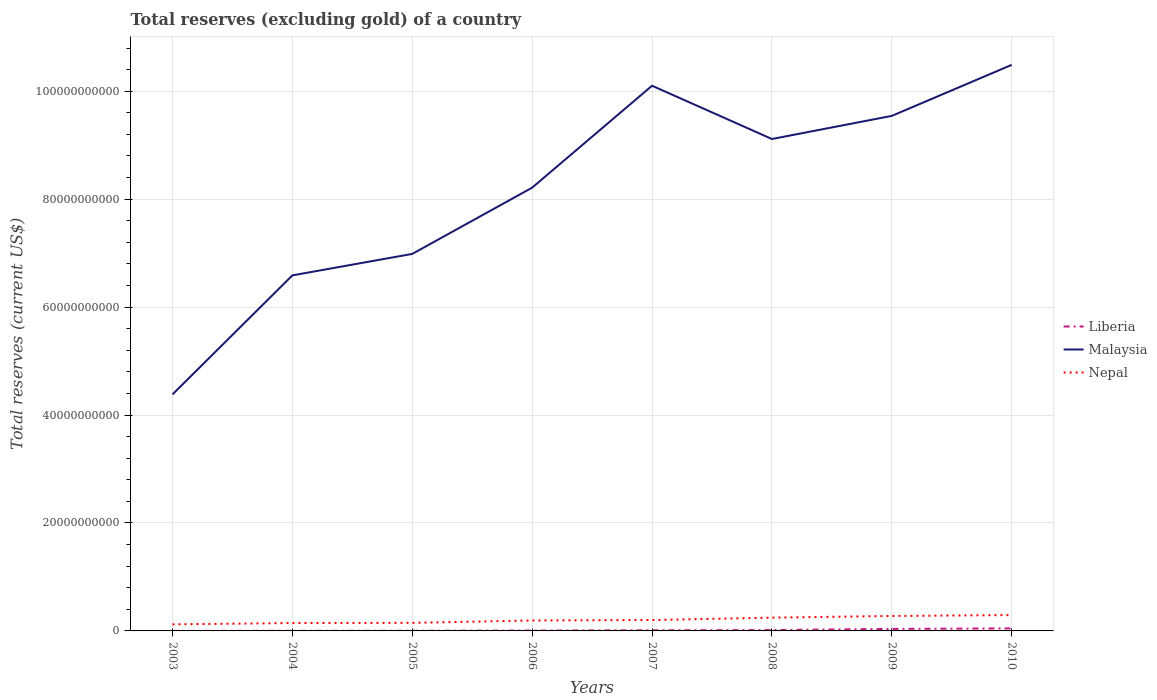How many different coloured lines are there?
Give a very brief answer. 3. Across all years, what is the maximum total reserves (excluding gold) in Liberia?
Offer a very short reply. 7.38e+06. In which year was the total reserves (excluding gold) in Nepal maximum?
Ensure brevity in your answer.  2003. What is the total total reserves (excluding gold) in Nepal in the graph?
Offer a very short reply. -7.85e+07. What is the difference between the highest and the second highest total reserves (excluding gold) in Malaysia?
Provide a short and direct response. 6.11e+1. How many years are there in the graph?
Provide a short and direct response. 8. Are the values on the major ticks of Y-axis written in scientific E-notation?
Your answer should be compact. No. How many legend labels are there?
Give a very brief answer. 3. How are the legend labels stacked?
Ensure brevity in your answer.  Vertical. What is the title of the graph?
Your response must be concise. Total reserves (excluding gold) of a country. Does "Haiti" appear as one of the legend labels in the graph?
Make the answer very short. No. What is the label or title of the X-axis?
Offer a terse response. Years. What is the label or title of the Y-axis?
Give a very brief answer. Total reserves (current US$). What is the Total reserves (current US$) of Liberia in 2003?
Ensure brevity in your answer.  7.38e+06. What is the Total reserves (current US$) in Malaysia in 2003?
Keep it short and to the point. 4.38e+1. What is the Total reserves (current US$) of Nepal in 2003?
Your answer should be compact. 1.22e+09. What is the Total reserves (current US$) of Liberia in 2004?
Your answer should be compact. 1.87e+07. What is the Total reserves (current US$) in Malaysia in 2004?
Give a very brief answer. 6.59e+1. What is the Total reserves (current US$) in Nepal in 2004?
Your answer should be very brief. 1.46e+09. What is the Total reserves (current US$) of Liberia in 2005?
Provide a short and direct response. 2.54e+07. What is the Total reserves (current US$) of Malaysia in 2005?
Provide a short and direct response. 6.99e+1. What is the Total reserves (current US$) of Nepal in 2005?
Offer a very short reply. 1.50e+09. What is the Total reserves (current US$) in Liberia in 2006?
Keep it short and to the point. 7.20e+07. What is the Total reserves (current US$) of Malaysia in 2006?
Offer a very short reply. 8.21e+1. What is the Total reserves (current US$) of Nepal in 2006?
Give a very brief answer. 1.94e+09. What is the Total reserves (current US$) in Liberia in 2007?
Your answer should be compact. 1.19e+08. What is the Total reserves (current US$) of Malaysia in 2007?
Ensure brevity in your answer.  1.01e+11. What is the Total reserves (current US$) in Nepal in 2007?
Provide a short and direct response. 2.01e+09. What is the Total reserves (current US$) in Liberia in 2008?
Your answer should be compact. 1.61e+08. What is the Total reserves (current US$) of Malaysia in 2008?
Your answer should be compact. 9.11e+1. What is the Total reserves (current US$) in Nepal in 2008?
Keep it short and to the point. 2.46e+09. What is the Total reserves (current US$) in Liberia in 2009?
Your answer should be very brief. 3.72e+08. What is the Total reserves (current US$) in Malaysia in 2009?
Your answer should be compact. 9.54e+1. What is the Total reserves (current US$) of Nepal in 2009?
Offer a terse response. 2.77e+09. What is the Total reserves (current US$) in Liberia in 2010?
Your response must be concise. 4.66e+08. What is the Total reserves (current US$) in Malaysia in 2010?
Ensure brevity in your answer.  1.05e+11. What is the Total reserves (current US$) in Nepal in 2010?
Give a very brief answer. 2.94e+09. Across all years, what is the maximum Total reserves (current US$) of Liberia?
Provide a short and direct response. 4.66e+08. Across all years, what is the maximum Total reserves (current US$) in Malaysia?
Ensure brevity in your answer.  1.05e+11. Across all years, what is the maximum Total reserves (current US$) in Nepal?
Provide a succinct answer. 2.94e+09. Across all years, what is the minimum Total reserves (current US$) in Liberia?
Make the answer very short. 7.38e+06. Across all years, what is the minimum Total reserves (current US$) of Malaysia?
Keep it short and to the point. 4.38e+1. Across all years, what is the minimum Total reserves (current US$) of Nepal?
Make the answer very short. 1.22e+09. What is the total Total reserves (current US$) in Liberia in the graph?
Offer a terse response. 1.24e+09. What is the total Total reserves (current US$) in Malaysia in the graph?
Offer a very short reply. 6.54e+11. What is the total Total reserves (current US$) of Nepal in the graph?
Give a very brief answer. 1.63e+1. What is the difference between the Total reserves (current US$) of Liberia in 2003 and that in 2004?
Your answer should be very brief. -1.14e+07. What is the difference between the Total reserves (current US$) of Malaysia in 2003 and that in 2004?
Your answer should be compact. -2.21e+1. What is the difference between the Total reserves (current US$) in Nepal in 2003 and that in 2004?
Keep it short and to the point. -2.40e+08. What is the difference between the Total reserves (current US$) in Liberia in 2003 and that in 2005?
Provide a short and direct response. -1.80e+07. What is the difference between the Total reserves (current US$) in Malaysia in 2003 and that in 2005?
Your answer should be compact. -2.60e+1. What is the difference between the Total reserves (current US$) of Nepal in 2003 and that in 2005?
Give a very brief answer. -2.77e+08. What is the difference between the Total reserves (current US$) in Liberia in 2003 and that in 2006?
Give a very brief answer. -6.46e+07. What is the difference between the Total reserves (current US$) in Malaysia in 2003 and that in 2006?
Offer a very short reply. -3.83e+1. What is the difference between the Total reserves (current US$) in Nepal in 2003 and that in 2006?
Your response must be concise. -7.13e+08. What is the difference between the Total reserves (current US$) of Liberia in 2003 and that in 2007?
Your answer should be compact. -1.12e+08. What is the difference between the Total reserves (current US$) of Malaysia in 2003 and that in 2007?
Provide a short and direct response. -5.72e+1. What is the difference between the Total reserves (current US$) in Nepal in 2003 and that in 2007?
Keep it short and to the point. -7.92e+08. What is the difference between the Total reserves (current US$) of Liberia in 2003 and that in 2008?
Your answer should be very brief. -1.53e+08. What is the difference between the Total reserves (current US$) in Malaysia in 2003 and that in 2008?
Provide a short and direct response. -4.73e+1. What is the difference between the Total reserves (current US$) in Nepal in 2003 and that in 2008?
Offer a very short reply. -1.24e+09. What is the difference between the Total reserves (current US$) of Liberia in 2003 and that in 2009?
Make the answer very short. -3.65e+08. What is the difference between the Total reserves (current US$) in Malaysia in 2003 and that in 2009?
Provide a short and direct response. -5.16e+1. What is the difference between the Total reserves (current US$) of Nepal in 2003 and that in 2009?
Provide a short and direct response. -1.55e+09. What is the difference between the Total reserves (current US$) in Liberia in 2003 and that in 2010?
Offer a very short reply. -4.59e+08. What is the difference between the Total reserves (current US$) of Malaysia in 2003 and that in 2010?
Keep it short and to the point. -6.11e+1. What is the difference between the Total reserves (current US$) in Nepal in 2003 and that in 2010?
Your response must be concise. -1.71e+09. What is the difference between the Total reserves (current US$) of Liberia in 2004 and that in 2005?
Your response must be concise. -6.65e+06. What is the difference between the Total reserves (current US$) of Malaysia in 2004 and that in 2005?
Your response must be concise. -3.98e+09. What is the difference between the Total reserves (current US$) of Nepal in 2004 and that in 2005?
Your answer should be very brief. -3.68e+07. What is the difference between the Total reserves (current US$) in Liberia in 2004 and that in 2006?
Your response must be concise. -5.32e+07. What is the difference between the Total reserves (current US$) in Malaysia in 2004 and that in 2006?
Your answer should be compact. -1.63e+1. What is the difference between the Total reserves (current US$) in Nepal in 2004 and that in 2006?
Provide a succinct answer. -4.73e+08. What is the difference between the Total reserves (current US$) of Liberia in 2004 and that in 2007?
Your response must be concise. -1.01e+08. What is the difference between the Total reserves (current US$) of Malaysia in 2004 and that in 2007?
Offer a terse response. -3.51e+1. What is the difference between the Total reserves (current US$) of Nepal in 2004 and that in 2007?
Offer a very short reply. -5.52e+08. What is the difference between the Total reserves (current US$) of Liberia in 2004 and that in 2008?
Keep it short and to the point. -1.42e+08. What is the difference between the Total reserves (current US$) in Malaysia in 2004 and that in 2008?
Offer a terse response. -2.53e+1. What is the difference between the Total reserves (current US$) in Nepal in 2004 and that in 2008?
Keep it short and to the point. -9.96e+08. What is the difference between the Total reserves (current US$) of Liberia in 2004 and that in 2009?
Make the answer very short. -3.54e+08. What is the difference between the Total reserves (current US$) of Malaysia in 2004 and that in 2009?
Give a very brief answer. -2.96e+1. What is the difference between the Total reserves (current US$) of Nepal in 2004 and that in 2009?
Provide a succinct answer. -1.31e+09. What is the difference between the Total reserves (current US$) of Liberia in 2004 and that in 2010?
Your response must be concise. -4.47e+08. What is the difference between the Total reserves (current US$) of Malaysia in 2004 and that in 2010?
Make the answer very short. -3.90e+1. What is the difference between the Total reserves (current US$) of Nepal in 2004 and that in 2010?
Keep it short and to the point. -1.47e+09. What is the difference between the Total reserves (current US$) of Liberia in 2005 and that in 2006?
Provide a short and direct response. -4.66e+07. What is the difference between the Total reserves (current US$) in Malaysia in 2005 and that in 2006?
Ensure brevity in your answer.  -1.23e+1. What is the difference between the Total reserves (current US$) in Nepal in 2005 and that in 2006?
Make the answer very short. -4.37e+08. What is the difference between the Total reserves (current US$) in Liberia in 2005 and that in 2007?
Give a very brief answer. -9.40e+07. What is the difference between the Total reserves (current US$) in Malaysia in 2005 and that in 2007?
Provide a succinct answer. -3.12e+1. What is the difference between the Total reserves (current US$) in Nepal in 2005 and that in 2007?
Keep it short and to the point. -5.15e+08. What is the difference between the Total reserves (current US$) of Liberia in 2005 and that in 2008?
Your answer should be very brief. -1.35e+08. What is the difference between the Total reserves (current US$) of Malaysia in 2005 and that in 2008?
Ensure brevity in your answer.  -2.13e+1. What is the difference between the Total reserves (current US$) in Nepal in 2005 and that in 2008?
Your answer should be compact. -9.59e+08. What is the difference between the Total reserves (current US$) in Liberia in 2005 and that in 2009?
Make the answer very short. -3.47e+08. What is the difference between the Total reserves (current US$) of Malaysia in 2005 and that in 2009?
Provide a short and direct response. -2.56e+1. What is the difference between the Total reserves (current US$) in Nepal in 2005 and that in 2009?
Ensure brevity in your answer.  -1.27e+09. What is the difference between the Total reserves (current US$) of Liberia in 2005 and that in 2010?
Ensure brevity in your answer.  -4.41e+08. What is the difference between the Total reserves (current US$) in Malaysia in 2005 and that in 2010?
Keep it short and to the point. -3.50e+1. What is the difference between the Total reserves (current US$) of Nepal in 2005 and that in 2010?
Your answer should be very brief. -1.44e+09. What is the difference between the Total reserves (current US$) in Liberia in 2006 and that in 2007?
Offer a terse response. -4.74e+07. What is the difference between the Total reserves (current US$) of Malaysia in 2006 and that in 2007?
Make the answer very short. -1.89e+1. What is the difference between the Total reserves (current US$) in Nepal in 2006 and that in 2007?
Provide a short and direct response. -7.85e+07. What is the difference between the Total reserves (current US$) in Liberia in 2006 and that in 2008?
Your answer should be very brief. -8.89e+07. What is the difference between the Total reserves (current US$) of Malaysia in 2006 and that in 2008?
Ensure brevity in your answer.  -9.02e+09. What is the difference between the Total reserves (current US$) of Nepal in 2006 and that in 2008?
Offer a very short reply. -5.22e+08. What is the difference between the Total reserves (current US$) in Liberia in 2006 and that in 2009?
Provide a short and direct response. -3.00e+08. What is the difference between the Total reserves (current US$) in Malaysia in 2006 and that in 2009?
Ensure brevity in your answer.  -1.33e+1. What is the difference between the Total reserves (current US$) of Nepal in 2006 and that in 2009?
Keep it short and to the point. -8.33e+08. What is the difference between the Total reserves (current US$) of Liberia in 2006 and that in 2010?
Keep it short and to the point. -3.94e+08. What is the difference between the Total reserves (current US$) of Malaysia in 2006 and that in 2010?
Provide a short and direct response. -2.28e+1. What is the difference between the Total reserves (current US$) in Nepal in 2006 and that in 2010?
Your response must be concise. -1.00e+09. What is the difference between the Total reserves (current US$) of Liberia in 2007 and that in 2008?
Ensure brevity in your answer.  -4.15e+07. What is the difference between the Total reserves (current US$) in Malaysia in 2007 and that in 2008?
Offer a very short reply. 9.87e+09. What is the difference between the Total reserves (current US$) of Nepal in 2007 and that in 2008?
Keep it short and to the point. -4.44e+08. What is the difference between the Total reserves (current US$) of Liberia in 2007 and that in 2009?
Provide a succinct answer. -2.53e+08. What is the difference between the Total reserves (current US$) of Malaysia in 2007 and that in 2009?
Your response must be concise. 5.59e+09. What is the difference between the Total reserves (current US$) in Nepal in 2007 and that in 2009?
Ensure brevity in your answer.  -7.55e+08. What is the difference between the Total reserves (current US$) of Liberia in 2007 and that in 2010?
Keep it short and to the point. -3.47e+08. What is the difference between the Total reserves (current US$) in Malaysia in 2007 and that in 2010?
Offer a very short reply. -3.86e+09. What is the difference between the Total reserves (current US$) in Nepal in 2007 and that in 2010?
Your answer should be very brief. -9.23e+08. What is the difference between the Total reserves (current US$) in Liberia in 2008 and that in 2009?
Ensure brevity in your answer.  -2.12e+08. What is the difference between the Total reserves (current US$) of Malaysia in 2008 and that in 2009?
Ensure brevity in your answer.  -4.28e+09. What is the difference between the Total reserves (current US$) of Nepal in 2008 and that in 2009?
Keep it short and to the point. -3.11e+08. What is the difference between the Total reserves (current US$) of Liberia in 2008 and that in 2010?
Make the answer very short. -3.05e+08. What is the difference between the Total reserves (current US$) in Malaysia in 2008 and that in 2010?
Give a very brief answer. -1.37e+1. What is the difference between the Total reserves (current US$) of Nepal in 2008 and that in 2010?
Keep it short and to the point. -4.79e+08. What is the difference between the Total reserves (current US$) in Liberia in 2009 and that in 2010?
Make the answer very short. -9.34e+07. What is the difference between the Total reserves (current US$) of Malaysia in 2009 and that in 2010?
Ensure brevity in your answer.  -9.45e+09. What is the difference between the Total reserves (current US$) in Nepal in 2009 and that in 2010?
Offer a terse response. -1.68e+08. What is the difference between the Total reserves (current US$) of Liberia in 2003 and the Total reserves (current US$) of Malaysia in 2004?
Your answer should be very brief. -6.59e+1. What is the difference between the Total reserves (current US$) of Liberia in 2003 and the Total reserves (current US$) of Nepal in 2004?
Provide a short and direct response. -1.45e+09. What is the difference between the Total reserves (current US$) of Malaysia in 2003 and the Total reserves (current US$) of Nepal in 2004?
Keep it short and to the point. 4.24e+1. What is the difference between the Total reserves (current US$) of Liberia in 2003 and the Total reserves (current US$) of Malaysia in 2005?
Make the answer very short. -6.99e+1. What is the difference between the Total reserves (current US$) of Liberia in 2003 and the Total reserves (current US$) of Nepal in 2005?
Give a very brief answer. -1.49e+09. What is the difference between the Total reserves (current US$) of Malaysia in 2003 and the Total reserves (current US$) of Nepal in 2005?
Offer a very short reply. 4.23e+1. What is the difference between the Total reserves (current US$) in Liberia in 2003 and the Total reserves (current US$) in Malaysia in 2006?
Keep it short and to the point. -8.21e+1. What is the difference between the Total reserves (current US$) of Liberia in 2003 and the Total reserves (current US$) of Nepal in 2006?
Your answer should be very brief. -1.93e+09. What is the difference between the Total reserves (current US$) in Malaysia in 2003 and the Total reserves (current US$) in Nepal in 2006?
Your answer should be very brief. 4.19e+1. What is the difference between the Total reserves (current US$) of Liberia in 2003 and the Total reserves (current US$) of Malaysia in 2007?
Provide a short and direct response. -1.01e+11. What is the difference between the Total reserves (current US$) of Liberia in 2003 and the Total reserves (current US$) of Nepal in 2007?
Make the answer very short. -2.01e+09. What is the difference between the Total reserves (current US$) in Malaysia in 2003 and the Total reserves (current US$) in Nepal in 2007?
Offer a terse response. 4.18e+1. What is the difference between the Total reserves (current US$) in Liberia in 2003 and the Total reserves (current US$) in Malaysia in 2008?
Give a very brief answer. -9.11e+1. What is the difference between the Total reserves (current US$) of Liberia in 2003 and the Total reserves (current US$) of Nepal in 2008?
Your response must be concise. -2.45e+09. What is the difference between the Total reserves (current US$) in Malaysia in 2003 and the Total reserves (current US$) in Nepal in 2008?
Provide a short and direct response. 4.14e+1. What is the difference between the Total reserves (current US$) of Liberia in 2003 and the Total reserves (current US$) of Malaysia in 2009?
Your answer should be very brief. -9.54e+1. What is the difference between the Total reserves (current US$) of Liberia in 2003 and the Total reserves (current US$) of Nepal in 2009?
Offer a very short reply. -2.76e+09. What is the difference between the Total reserves (current US$) in Malaysia in 2003 and the Total reserves (current US$) in Nepal in 2009?
Provide a succinct answer. 4.11e+1. What is the difference between the Total reserves (current US$) of Liberia in 2003 and the Total reserves (current US$) of Malaysia in 2010?
Ensure brevity in your answer.  -1.05e+11. What is the difference between the Total reserves (current US$) in Liberia in 2003 and the Total reserves (current US$) in Nepal in 2010?
Your answer should be compact. -2.93e+09. What is the difference between the Total reserves (current US$) in Malaysia in 2003 and the Total reserves (current US$) in Nepal in 2010?
Provide a short and direct response. 4.09e+1. What is the difference between the Total reserves (current US$) in Liberia in 2004 and the Total reserves (current US$) in Malaysia in 2005?
Your response must be concise. -6.98e+1. What is the difference between the Total reserves (current US$) in Liberia in 2004 and the Total reserves (current US$) in Nepal in 2005?
Your answer should be very brief. -1.48e+09. What is the difference between the Total reserves (current US$) in Malaysia in 2004 and the Total reserves (current US$) in Nepal in 2005?
Your answer should be compact. 6.44e+1. What is the difference between the Total reserves (current US$) in Liberia in 2004 and the Total reserves (current US$) in Malaysia in 2006?
Your answer should be compact. -8.21e+1. What is the difference between the Total reserves (current US$) in Liberia in 2004 and the Total reserves (current US$) in Nepal in 2006?
Make the answer very short. -1.92e+09. What is the difference between the Total reserves (current US$) in Malaysia in 2004 and the Total reserves (current US$) in Nepal in 2006?
Your answer should be compact. 6.39e+1. What is the difference between the Total reserves (current US$) of Liberia in 2004 and the Total reserves (current US$) of Malaysia in 2007?
Offer a very short reply. -1.01e+11. What is the difference between the Total reserves (current US$) of Liberia in 2004 and the Total reserves (current US$) of Nepal in 2007?
Your answer should be compact. -2.00e+09. What is the difference between the Total reserves (current US$) in Malaysia in 2004 and the Total reserves (current US$) in Nepal in 2007?
Your answer should be very brief. 6.39e+1. What is the difference between the Total reserves (current US$) in Liberia in 2004 and the Total reserves (current US$) in Malaysia in 2008?
Your answer should be compact. -9.11e+1. What is the difference between the Total reserves (current US$) of Liberia in 2004 and the Total reserves (current US$) of Nepal in 2008?
Your response must be concise. -2.44e+09. What is the difference between the Total reserves (current US$) of Malaysia in 2004 and the Total reserves (current US$) of Nepal in 2008?
Offer a very short reply. 6.34e+1. What is the difference between the Total reserves (current US$) of Liberia in 2004 and the Total reserves (current US$) of Malaysia in 2009?
Provide a short and direct response. -9.54e+1. What is the difference between the Total reserves (current US$) in Liberia in 2004 and the Total reserves (current US$) in Nepal in 2009?
Offer a terse response. -2.75e+09. What is the difference between the Total reserves (current US$) of Malaysia in 2004 and the Total reserves (current US$) of Nepal in 2009?
Your response must be concise. 6.31e+1. What is the difference between the Total reserves (current US$) in Liberia in 2004 and the Total reserves (current US$) in Malaysia in 2010?
Offer a very short reply. -1.05e+11. What is the difference between the Total reserves (current US$) in Liberia in 2004 and the Total reserves (current US$) in Nepal in 2010?
Offer a very short reply. -2.92e+09. What is the difference between the Total reserves (current US$) in Malaysia in 2004 and the Total reserves (current US$) in Nepal in 2010?
Provide a short and direct response. 6.29e+1. What is the difference between the Total reserves (current US$) of Liberia in 2005 and the Total reserves (current US$) of Malaysia in 2006?
Offer a very short reply. -8.21e+1. What is the difference between the Total reserves (current US$) of Liberia in 2005 and the Total reserves (current US$) of Nepal in 2006?
Provide a short and direct response. -1.91e+09. What is the difference between the Total reserves (current US$) in Malaysia in 2005 and the Total reserves (current US$) in Nepal in 2006?
Keep it short and to the point. 6.79e+1. What is the difference between the Total reserves (current US$) of Liberia in 2005 and the Total reserves (current US$) of Malaysia in 2007?
Your response must be concise. -1.01e+11. What is the difference between the Total reserves (current US$) of Liberia in 2005 and the Total reserves (current US$) of Nepal in 2007?
Keep it short and to the point. -1.99e+09. What is the difference between the Total reserves (current US$) of Malaysia in 2005 and the Total reserves (current US$) of Nepal in 2007?
Provide a short and direct response. 6.78e+1. What is the difference between the Total reserves (current US$) in Liberia in 2005 and the Total reserves (current US$) in Malaysia in 2008?
Offer a terse response. -9.11e+1. What is the difference between the Total reserves (current US$) in Liberia in 2005 and the Total reserves (current US$) in Nepal in 2008?
Your response must be concise. -2.43e+09. What is the difference between the Total reserves (current US$) in Malaysia in 2005 and the Total reserves (current US$) in Nepal in 2008?
Offer a very short reply. 6.74e+1. What is the difference between the Total reserves (current US$) in Liberia in 2005 and the Total reserves (current US$) in Malaysia in 2009?
Give a very brief answer. -9.54e+1. What is the difference between the Total reserves (current US$) of Liberia in 2005 and the Total reserves (current US$) of Nepal in 2009?
Offer a terse response. -2.74e+09. What is the difference between the Total reserves (current US$) in Malaysia in 2005 and the Total reserves (current US$) in Nepal in 2009?
Provide a short and direct response. 6.71e+1. What is the difference between the Total reserves (current US$) of Liberia in 2005 and the Total reserves (current US$) of Malaysia in 2010?
Give a very brief answer. -1.05e+11. What is the difference between the Total reserves (current US$) in Liberia in 2005 and the Total reserves (current US$) in Nepal in 2010?
Ensure brevity in your answer.  -2.91e+09. What is the difference between the Total reserves (current US$) of Malaysia in 2005 and the Total reserves (current US$) of Nepal in 2010?
Your answer should be very brief. 6.69e+1. What is the difference between the Total reserves (current US$) of Liberia in 2006 and the Total reserves (current US$) of Malaysia in 2007?
Give a very brief answer. -1.01e+11. What is the difference between the Total reserves (current US$) in Liberia in 2006 and the Total reserves (current US$) in Nepal in 2007?
Your answer should be compact. -1.94e+09. What is the difference between the Total reserves (current US$) of Malaysia in 2006 and the Total reserves (current US$) of Nepal in 2007?
Give a very brief answer. 8.01e+1. What is the difference between the Total reserves (current US$) in Liberia in 2006 and the Total reserves (current US$) in Malaysia in 2008?
Ensure brevity in your answer.  -9.11e+1. What is the difference between the Total reserves (current US$) in Liberia in 2006 and the Total reserves (current US$) in Nepal in 2008?
Your response must be concise. -2.39e+09. What is the difference between the Total reserves (current US$) of Malaysia in 2006 and the Total reserves (current US$) of Nepal in 2008?
Offer a terse response. 7.97e+1. What is the difference between the Total reserves (current US$) of Liberia in 2006 and the Total reserves (current US$) of Malaysia in 2009?
Keep it short and to the point. -9.54e+1. What is the difference between the Total reserves (current US$) of Liberia in 2006 and the Total reserves (current US$) of Nepal in 2009?
Provide a short and direct response. -2.70e+09. What is the difference between the Total reserves (current US$) in Malaysia in 2006 and the Total reserves (current US$) in Nepal in 2009?
Offer a terse response. 7.94e+1. What is the difference between the Total reserves (current US$) in Liberia in 2006 and the Total reserves (current US$) in Malaysia in 2010?
Your answer should be very brief. -1.05e+11. What is the difference between the Total reserves (current US$) of Liberia in 2006 and the Total reserves (current US$) of Nepal in 2010?
Your answer should be compact. -2.86e+09. What is the difference between the Total reserves (current US$) of Malaysia in 2006 and the Total reserves (current US$) of Nepal in 2010?
Offer a terse response. 7.92e+1. What is the difference between the Total reserves (current US$) of Liberia in 2007 and the Total reserves (current US$) of Malaysia in 2008?
Offer a very short reply. -9.10e+1. What is the difference between the Total reserves (current US$) of Liberia in 2007 and the Total reserves (current US$) of Nepal in 2008?
Ensure brevity in your answer.  -2.34e+09. What is the difference between the Total reserves (current US$) of Malaysia in 2007 and the Total reserves (current US$) of Nepal in 2008?
Provide a succinct answer. 9.86e+1. What is the difference between the Total reserves (current US$) in Liberia in 2007 and the Total reserves (current US$) in Malaysia in 2009?
Offer a terse response. -9.53e+1. What is the difference between the Total reserves (current US$) of Liberia in 2007 and the Total reserves (current US$) of Nepal in 2009?
Provide a short and direct response. -2.65e+09. What is the difference between the Total reserves (current US$) of Malaysia in 2007 and the Total reserves (current US$) of Nepal in 2009?
Your response must be concise. 9.83e+1. What is the difference between the Total reserves (current US$) in Liberia in 2007 and the Total reserves (current US$) in Malaysia in 2010?
Provide a short and direct response. -1.05e+11. What is the difference between the Total reserves (current US$) in Liberia in 2007 and the Total reserves (current US$) in Nepal in 2010?
Offer a terse response. -2.82e+09. What is the difference between the Total reserves (current US$) in Malaysia in 2007 and the Total reserves (current US$) in Nepal in 2010?
Make the answer very short. 9.81e+1. What is the difference between the Total reserves (current US$) of Liberia in 2008 and the Total reserves (current US$) of Malaysia in 2009?
Make the answer very short. -9.53e+1. What is the difference between the Total reserves (current US$) in Liberia in 2008 and the Total reserves (current US$) in Nepal in 2009?
Make the answer very short. -2.61e+09. What is the difference between the Total reserves (current US$) in Malaysia in 2008 and the Total reserves (current US$) in Nepal in 2009?
Keep it short and to the point. 8.84e+1. What is the difference between the Total reserves (current US$) of Liberia in 2008 and the Total reserves (current US$) of Malaysia in 2010?
Offer a terse response. -1.05e+11. What is the difference between the Total reserves (current US$) in Liberia in 2008 and the Total reserves (current US$) in Nepal in 2010?
Your response must be concise. -2.78e+09. What is the difference between the Total reserves (current US$) in Malaysia in 2008 and the Total reserves (current US$) in Nepal in 2010?
Offer a terse response. 8.82e+1. What is the difference between the Total reserves (current US$) of Liberia in 2009 and the Total reserves (current US$) of Malaysia in 2010?
Offer a very short reply. -1.05e+11. What is the difference between the Total reserves (current US$) of Liberia in 2009 and the Total reserves (current US$) of Nepal in 2010?
Keep it short and to the point. -2.56e+09. What is the difference between the Total reserves (current US$) of Malaysia in 2009 and the Total reserves (current US$) of Nepal in 2010?
Your answer should be very brief. 9.25e+1. What is the average Total reserves (current US$) in Liberia per year?
Offer a terse response. 1.55e+08. What is the average Total reserves (current US$) in Malaysia per year?
Your answer should be very brief. 8.18e+1. What is the average Total reserves (current US$) in Nepal per year?
Keep it short and to the point. 2.04e+09. In the year 2003, what is the difference between the Total reserves (current US$) in Liberia and Total reserves (current US$) in Malaysia?
Provide a short and direct response. -4.38e+1. In the year 2003, what is the difference between the Total reserves (current US$) of Liberia and Total reserves (current US$) of Nepal?
Provide a succinct answer. -1.22e+09. In the year 2003, what is the difference between the Total reserves (current US$) of Malaysia and Total reserves (current US$) of Nepal?
Keep it short and to the point. 4.26e+1. In the year 2004, what is the difference between the Total reserves (current US$) in Liberia and Total reserves (current US$) in Malaysia?
Offer a terse response. -6.59e+1. In the year 2004, what is the difference between the Total reserves (current US$) in Liberia and Total reserves (current US$) in Nepal?
Offer a very short reply. -1.44e+09. In the year 2004, what is the difference between the Total reserves (current US$) of Malaysia and Total reserves (current US$) of Nepal?
Ensure brevity in your answer.  6.44e+1. In the year 2005, what is the difference between the Total reserves (current US$) of Liberia and Total reserves (current US$) of Malaysia?
Your answer should be compact. -6.98e+1. In the year 2005, what is the difference between the Total reserves (current US$) of Liberia and Total reserves (current US$) of Nepal?
Your answer should be compact. -1.47e+09. In the year 2005, what is the difference between the Total reserves (current US$) of Malaysia and Total reserves (current US$) of Nepal?
Keep it short and to the point. 6.84e+1. In the year 2006, what is the difference between the Total reserves (current US$) in Liberia and Total reserves (current US$) in Malaysia?
Your answer should be compact. -8.21e+1. In the year 2006, what is the difference between the Total reserves (current US$) in Liberia and Total reserves (current US$) in Nepal?
Keep it short and to the point. -1.86e+09. In the year 2006, what is the difference between the Total reserves (current US$) in Malaysia and Total reserves (current US$) in Nepal?
Your answer should be compact. 8.02e+1. In the year 2007, what is the difference between the Total reserves (current US$) in Liberia and Total reserves (current US$) in Malaysia?
Ensure brevity in your answer.  -1.01e+11. In the year 2007, what is the difference between the Total reserves (current US$) in Liberia and Total reserves (current US$) in Nepal?
Provide a short and direct response. -1.89e+09. In the year 2007, what is the difference between the Total reserves (current US$) in Malaysia and Total reserves (current US$) in Nepal?
Provide a short and direct response. 9.90e+1. In the year 2008, what is the difference between the Total reserves (current US$) of Liberia and Total reserves (current US$) of Malaysia?
Give a very brief answer. -9.10e+1. In the year 2008, what is the difference between the Total reserves (current US$) in Liberia and Total reserves (current US$) in Nepal?
Your response must be concise. -2.30e+09. In the year 2008, what is the difference between the Total reserves (current US$) in Malaysia and Total reserves (current US$) in Nepal?
Keep it short and to the point. 8.87e+1. In the year 2009, what is the difference between the Total reserves (current US$) of Liberia and Total reserves (current US$) of Malaysia?
Give a very brief answer. -9.51e+1. In the year 2009, what is the difference between the Total reserves (current US$) of Liberia and Total reserves (current US$) of Nepal?
Provide a short and direct response. -2.40e+09. In the year 2009, what is the difference between the Total reserves (current US$) in Malaysia and Total reserves (current US$) in Nepal?
Give a very brief answer. 9.27e+1. In the year 2010, what is the difference between the Total reserves (current US$) in Liberia and Total reserves (current US$) in Malaysia?
Offer a very short reply. -1.04e+11. In the year 2010, what is the difference between the Total reserves (current US$) of Liberia and Total reserves (current US$) of Nepal?
Ensure brevity in your answer.  -2.47e+09. In the year 2010, what is the difference between the Total reserves (current US$) in Malaysia and Total reserves (current US$) in Nepal?
Provide a short and direct response. 1.02e+11. What is the ratio of the Total reserves (current US$) of Liberia in 2003 to that in 2004?
Ensure brevity in your answer.  0.39. What is the ratio of the Total reserves (current US$) in Malaysia in 2003 to that in 2004?
Give a very brief answer. 0.67. What is the ratio of the Total reserves (current US$) of Nepal in 2003 to that in 2004?
Make the answer very short. 0.84. What is the ratio of the Total reserves (current US$) of Liberia in 2003 to that in 2005?
Your response must be concise. 0.29. What is the ratio of the Total reserves (current US$) in Malaysia in 2003 to that in 2005?
Your answer should be compact. 0.63. What is the ratio of the Total reserves (current US$) of Nepal in 2003 to that in 2005?
Offer a very short reply. 0.82. What is the ratio of the Total reserves (current US$) of Liberia in 2003 to that in 2006?
Provide a short and direct response. 0.1. What is the ratio of the Total reserves (current US$) in Malaysia in 2003 to that in 2006?
Provide a succinct answer. 0.53. What is the ratio of the Total reserves (current US$) in Nepal in 2003 to that in 2006?
Your answer should be compact. 0.63. What is the ratio of the Total reserves (current US$) of Liberia in 2003 to that in 2007?
Make the answer very short. 0.06. What is the ratio of the Total reserves (current US$) in Malaysia in 2003 to that in 2007?
Ensure brevity in your answer.  0.43. What is the ratio of the Total reserves (current US$) of Nepal in 2003 to that in 2007?
Make the answer very short. 0.61. What is the ratio of the Total reserves (current US$) of Liberia in 2003 to that in 2008?
Your answer should be compact. 0.05. What is the ratio of the Total reserves (current US$) in Malaysia in 2003 to that in 2008?
Offer a very short reply. 0.48. What is the ratio of the Total reserves (current US$) in Nepal in 2003 to that in 2008?
Provide a short and direct response. 0.5. What is the ratio of the Total reserves (current US$) of Liberia in 2003 to that in 2009?
Provide a succinct answer. 0.02. What is the ratio of the Total reserves (current US$) of Malaysia in 2003 to that in 2009?
Your answer should be very brief. 0.46. What is the ratio of the Total reserves (current US$) in Nepal in 2003 to that in 2009?
Provide a succinct answer. 0.44. What is the ratio of the Total reserves (current US$) in Liberia in 2003 to that in 2010?
Keep it short and to the point. 0.02. What is the ratio of the Total reserves (current US$) of Malaysia in 2003 to that in 2010?
Ensure brevity in your answer.  0.42. What is the ratio of the Total reserves (current US$) of Nepal in 2003 to that in 2010?
Keep it short and to the point. 0.42. What is the ratio of the Total reserves (current US$) of Liberia in 2004 to that in 2005?
Provide a succinct answer. 0.74. What is the ratio of the Total reserves (current US$) in Malaysia in 2004 to that in 2005?
Offer a very short reply. 0.94. What is the ratio of the Total reserves (current US$) in Nepal in 2004 to that in 2005?
Your answer should be compact. 0.98. What is the ratio of the Total reserves (current US$) of Liberia in 2004 to that in 2006?
Make the answer very short. 0.26. What is the ratio of the Total reserves (current US$) of Malaysia in 2004 to that in 2006?
Provide a succinct answer. 0.8. What is the ratio of the Total reserves (current US$) in Nepal in 2004 to that in 2006?
Ensure brevity in your answer.  0.76. What is the ratio of the Total reserves (current US$) of Liberia in 2004 to that in 2007?
Keep it short and to the point. 0.16. What is the ratio of the Total reserves (current US$) in Malaysia in 2004 to that in 2007?
Keep it short and to the point. 0.65. What is the ratio of the Total reserves (current US$) of Nepal in 2004 to that in 2007?
Offer a very short reply. 0.73. What is the ratio of the Total reserves (current US$) of Liberia in 2004 to that in 2008?
Offer a very short reply. 0.12. What is the ratio of the Total reserves (current US$) of Malaysia in 2004 to that in 2008?
Offer a very short reply. 0.72. What is the ratio of the Total reserves (current US$) of Nepal in 2004 to that in 2008?
Give a very brief answer. 0.59. What is the ratio of the Total reserves (current US$) in Liberia in 2004 to that in 2009?
Ensure brevity in your answer.  0.05. What is the ratio of the Total reserves (current US$) in Malaysia in 2004 to that in 2009?
Provide a succinct answer. 0.69. What is the ratio of the Total reserves (current US$) in Nepal in 2004 to that in 2009?
Ensure brevity in your answer.  0.53. What is the ratio of the Total reserves (current US$) in Liberia in 2004 to that in 2010?
Keep it short and to the point. 0.04. What is the ratio of the Total reserves (current US$) of Malaysia in 2004 to that in 2010?
Keep it short and to the point. 0.63. What is the ratio of the Total reserves (current US$) in Nepal in 2004 to that in 2010?
Your answer should be very brief. 0.5. What is the ratio of the Total reserves (current US$) of Liberia in 2005 to that in 2006?
Give a very brief answer. 0.35. What is the ratio of the Total reserves (current US$) in Malaysia in 2005 to that in 2006?
Make the answer very short. 0.85. What is the ratio of the Total reserves (current US$) in Nepal in 2005 to that in 2006?
Give a very brief answer. 0.77. What is the ratio of the Total reserves (current US$) of Liberia in 2005 to that in 2007?
Your answer should be compact. 0.21. What is the ratio of the Total reserves (current US$) of Malaysia in 2005 to that in 2007?
Keep it short and to the point. 0.69. What is the ratio of the Total reserves (current US$) in Nepal in 2005 to that in 2007?
Offer a very short reply. 0.74. What is the ratio of the Total reserves (current US$) of Liberia in 2005 to that in 2008?
Give a very brief answer. 0.16. What is the ratio of the Total reserves (current US$) of Malaysia in 2005 to that in 2008?
Provide a short and direct response. 0.77. What is the ratio of the Total reserves (current US$) in Nepal in 2005 to that in 2008?
Your answer should be very brief. 0.61. What is the ratio of the Total reserves (current US$) of Liberia in 2005 to that in 2009?
Your response must be concise. 0.07. What is the ratio of the Total reserves (current US$) in Malaysia in 2005 to that in 2009?
Ensure brevity in your answer.  0.73. What is the ratio of the Total reserves (current US$) in Nepal in 2005 to that in 2009?
Offer a terse response. 0.54. What is the ratio of the Total reserves (current US$) in Liberia in 2005 to that in 2010?
Offer a very short reply. 0.05. What is the ratio of the Total reserves (current US$) of Malaysia in 2005 to that in 2010?
Your response must be concise. 0.67. What is the ratio of the Total reserves (current US$) in Nepal in 2005 to that in 2010?
Your answer should be very brief. 0.51. What is the ratio of the Total reserves (current US$) of Liberia in 2006 to that in 2007?
Give a very brief answer. 0.6. What is the ratio of the Total reserves (current US$) of Malaysia in 2006 to that in 2007?
Your response must be concise. 0.81. What is the ratio of the Total reserves (current US$) of Liberia in 2006 to that in 2008?
Give a very brief answer. 0.45. What is the ratio of the Total reserves (current US$) in Malaysia in 2006 to that in 2008?
Keep it short and to the point. 0.9. What is the ratio of the Total reserves (current US$) in Nepal in 2006 to that in 2008?
Your answer should be compact. 0.79. What is the ratio of the Total reserves (current US$) of Liberia in 2006 to that in 2009?
Offer a terse response. 0.19. What is the ratio of the Total reserves (current US$) of Malaysia in 2006 to that in 2009?
Your response must be concise. 0.86. What is the ratio of the Total reserves (current US$) of Nepal in 2006 to that in 2009?
Provide a short and direct response. 0.7. What is the ratio of the Total reserves (current US$) in Liberia in 2006 to that in 2010?
Your answer should be very brief. 0.15. What is the ratio of the Total reserves (current US$) in Malaysia in 2006 to that in 2010?
Provide a short and direct response. 0.78. What is the ratio of the Total reserves (current US$) of Nepal in 2006 to that in 2010?
Offer a very short reply. 0.66. What is the ratio of the Total reserves (current US$) of Liberia in 2007 to that in 2008?
Give a very brief answer. 0.74. What is the ratio of the Total reserves (current US$) of Malaysia in 2007 to that in 2008?
Provide a succinct answer. 1.11. What is the ratio of the Total reserves (current US$) in Nepal in 2007 to that in 2008?
Give a very brief answer. 0.82. What is the ratio of the Total reserves (current US$) of Liberia in 2007 to that in 2009?
Your answer should be compact. 0.32. What is the ratio of the Total reserves (current US$) of Malaysia in 2007 to that in 2009?
Your response must be concise. 1.06. What is the ratio of the Total reserves (current US$) of Nepal in 2007 to that in 2009?
Your response must be concise. 0.73. What is the ratio of the Total reserves (current US$) of Liberia in 2007 to that in 2010?
Provide a short and direct response. 0.26. What is the ratio of the Total reserves (current US$) of Malaysia in 2007 to that in 2010?
Your answer should be very brief. 0.96. What is the ratio of the Total reserves (current US$) in Nepal in 2007 to that in 2010?
Provide a succinct answer. 0.69. What is the ratio of the Total reserves (current US$) in Liberia in 2008 to that in 2009?
Make the answer very short. 0.43. What is the ratio of the Total reserves (current US$) of Malaysia in 2008 to that in 2009?
Make the answer very short. 0.96. What is the ratio of the Total reserves (current US$) in Nepal in 2008 to that in 2009?
Provide a succinct answer. 0.89. What is the ratio of the Total reserves (current US$) of Liberia in 2008 to that in 2010?
Your answer should be very brief. 0.35. What is the ratio of the Total reserves (current US$) of Malaysia in 2008 to that in 2010?
Provide a succinct answer. 0.87. What is the ratio of the Total reserves (current US$) of Nepal in 2008 to that in 2010?
Your response must be concise. 0.84. What is the ratio of the Total reserves (current US$) of Liberia in 2009 to that in 2010?
Offer a terse response. 0.8. What is the ratio of the Total reserves (current US$) in Malaysia in 2009 to that in 2010?
Provide a succinct answer. 0.91. What is the ratio of the Total reserves (current US$) of Nepal in 2009 to that in 2010?
Keep it short and to the point. 0.94. What is the difference between the highest and the second highest Total reserves (current US$) of Liberia?
Provide a succinct answer. 9.34e+07. What is the difference between the highest and the second highest Total reserves (current US$) of Malaysia?
Give a very brief answer. 3.86e+09. What is the difference between the highest and the second highest Total reserves (current US$) in Nepal?
Offer a terse response. 1.68e+08. What is the difference between the highest and the lowest Total reserves (current US$) in Liberia?
Your answer should be compact. 4.59e+08. What is the difference between the highest and the lowest Total reserves (current US$) in Malaysia?
Offer a very short reply. 6.11e+1. What is the difference between the highest and the lowest Total reserves (current US$) of Nepal?
Give a very brief answer. 1.71e+09. 